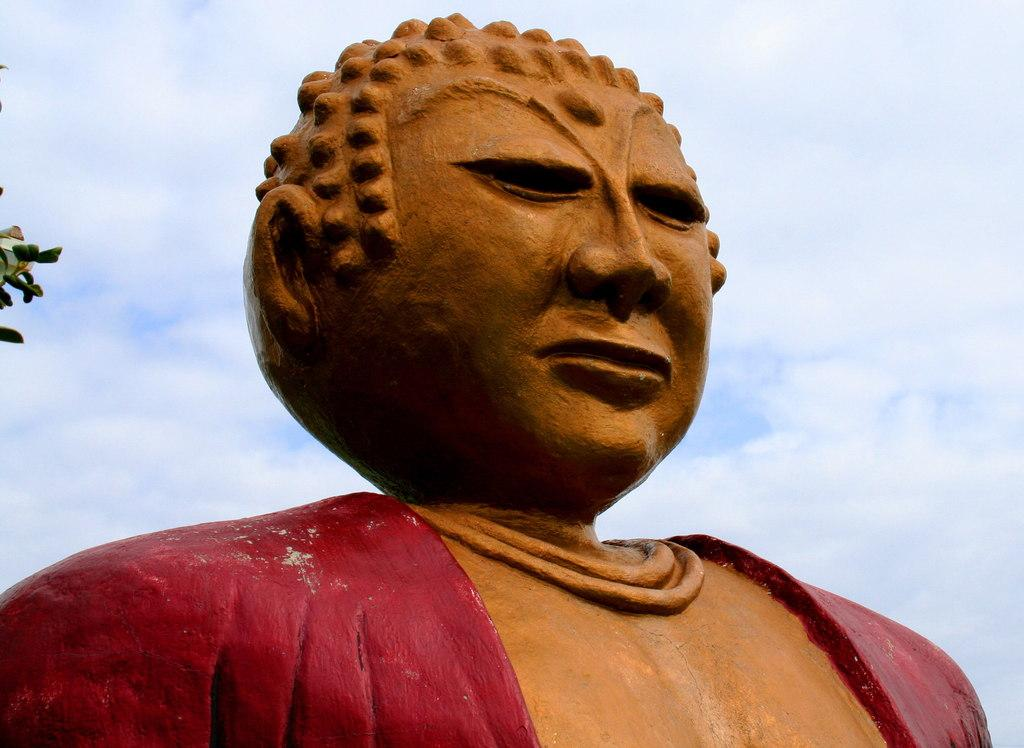What is the main subject in the image? There is a statue in the image. What is the condition of the sky in the image? The sky is fully covered with clouds. What type of vegetation can be seen on the left side of the image? Leaves are present on the left side of the image. How does the statue act in the image? The statue is an inanimate object and does not act in the image. 